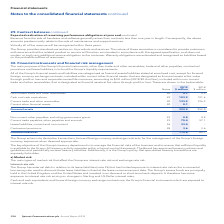According to Spirent Communications Plc's financial document, What is the total financial liabilities in 2019? According to the financial document, 112.8 (in millions). The relevant text states: "Financial liabilities 112.8 65.1..." Also, What is the key objective of the Group's treasury department? to manage the financial risks of the business and to ensure that sufficient liquidity is available to the Group. The document states: "y objective of the Group’s treasury department is to manage the financial risks of the business and to ensure that sufficient liquidity is available t..." Also, What are the components under Financial assets? The document contains multiple relevant values: Non-current trade and other receivables, Cash and cash equivalents, Current trade and other receivables, Current other financial assets. From the document: "Non-current trade and other receivables 20 5.7 3.5 Non-current trade and other receivables 20 5.7 3.5 Current other financial assets 20 0.1 – Cash and..." Additionally, In which year was the amount of Non-current trade and other receivables larger? According to the financial document, 2019. The relevant text states: "2019 2018 Notes $ million $ million..." Also, can you calculate: What was the change in Non-current trade and other receivables? Based on the calculation: 5.7-3.5, the result is 2.2 (in millions). This is based on the information: "Non-current trade and other receivables 20 5.7 3.5 Non-current trade and other receivables 20 5.7 3.5..." The key data points involved are: 3.5, 5.7. Also, can you calculate: What was the percentage change in Non-current trade and other receivables? To answer this question, I need to perform calculations using the financial data. The calculation is: (5.7-3.5)/3.5, which equals 62.86 (percentage). This is based on the information: "Non-current trade and other receivables 20 5.7 3.5 Non-current trade and other receivables 20 5.7 3.5..." The key data points involved are: 3.5, 5.7. 